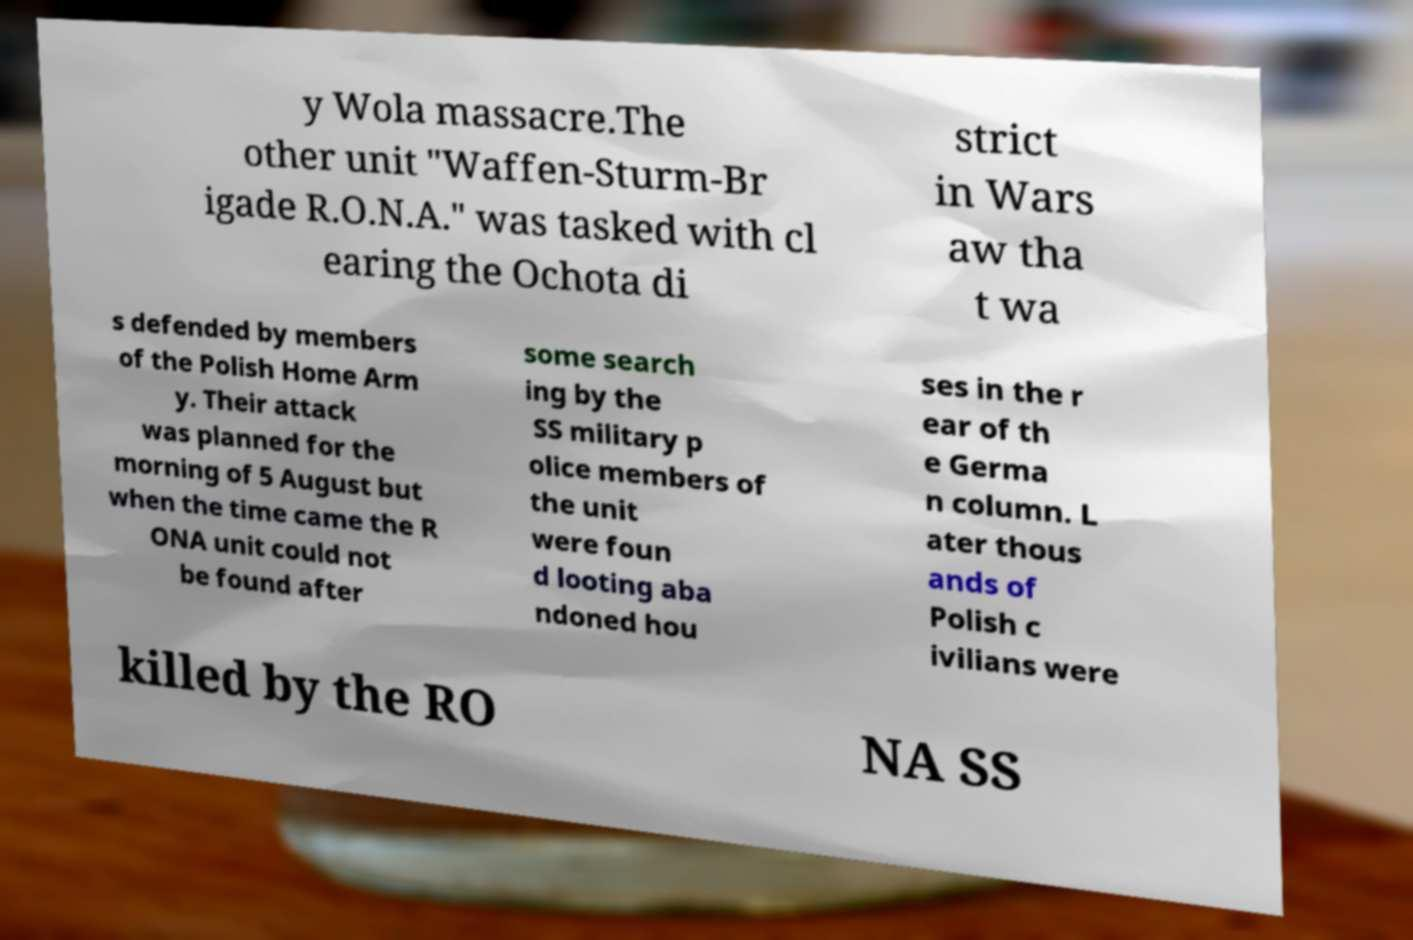Can you accurately transcribe the text from the provided image for me? y Wola massacre.The other unit "Waffen-Sturm-Br igade R.O.N.A." was tasked with cl earing the Ochota di strict in Wars aw tha t wa s defended by members of the Polish Home Arm y. Their attack was planned for the morning of 5 August but when the time came the R ONA unit could not be found after some search ing by the SS military p olice members of the unit were foun d looting aba ndoned hou ses in the r ear of th e Germa n column. L ater thous ands of Polish c ivilians were killed by the RO NA SS 